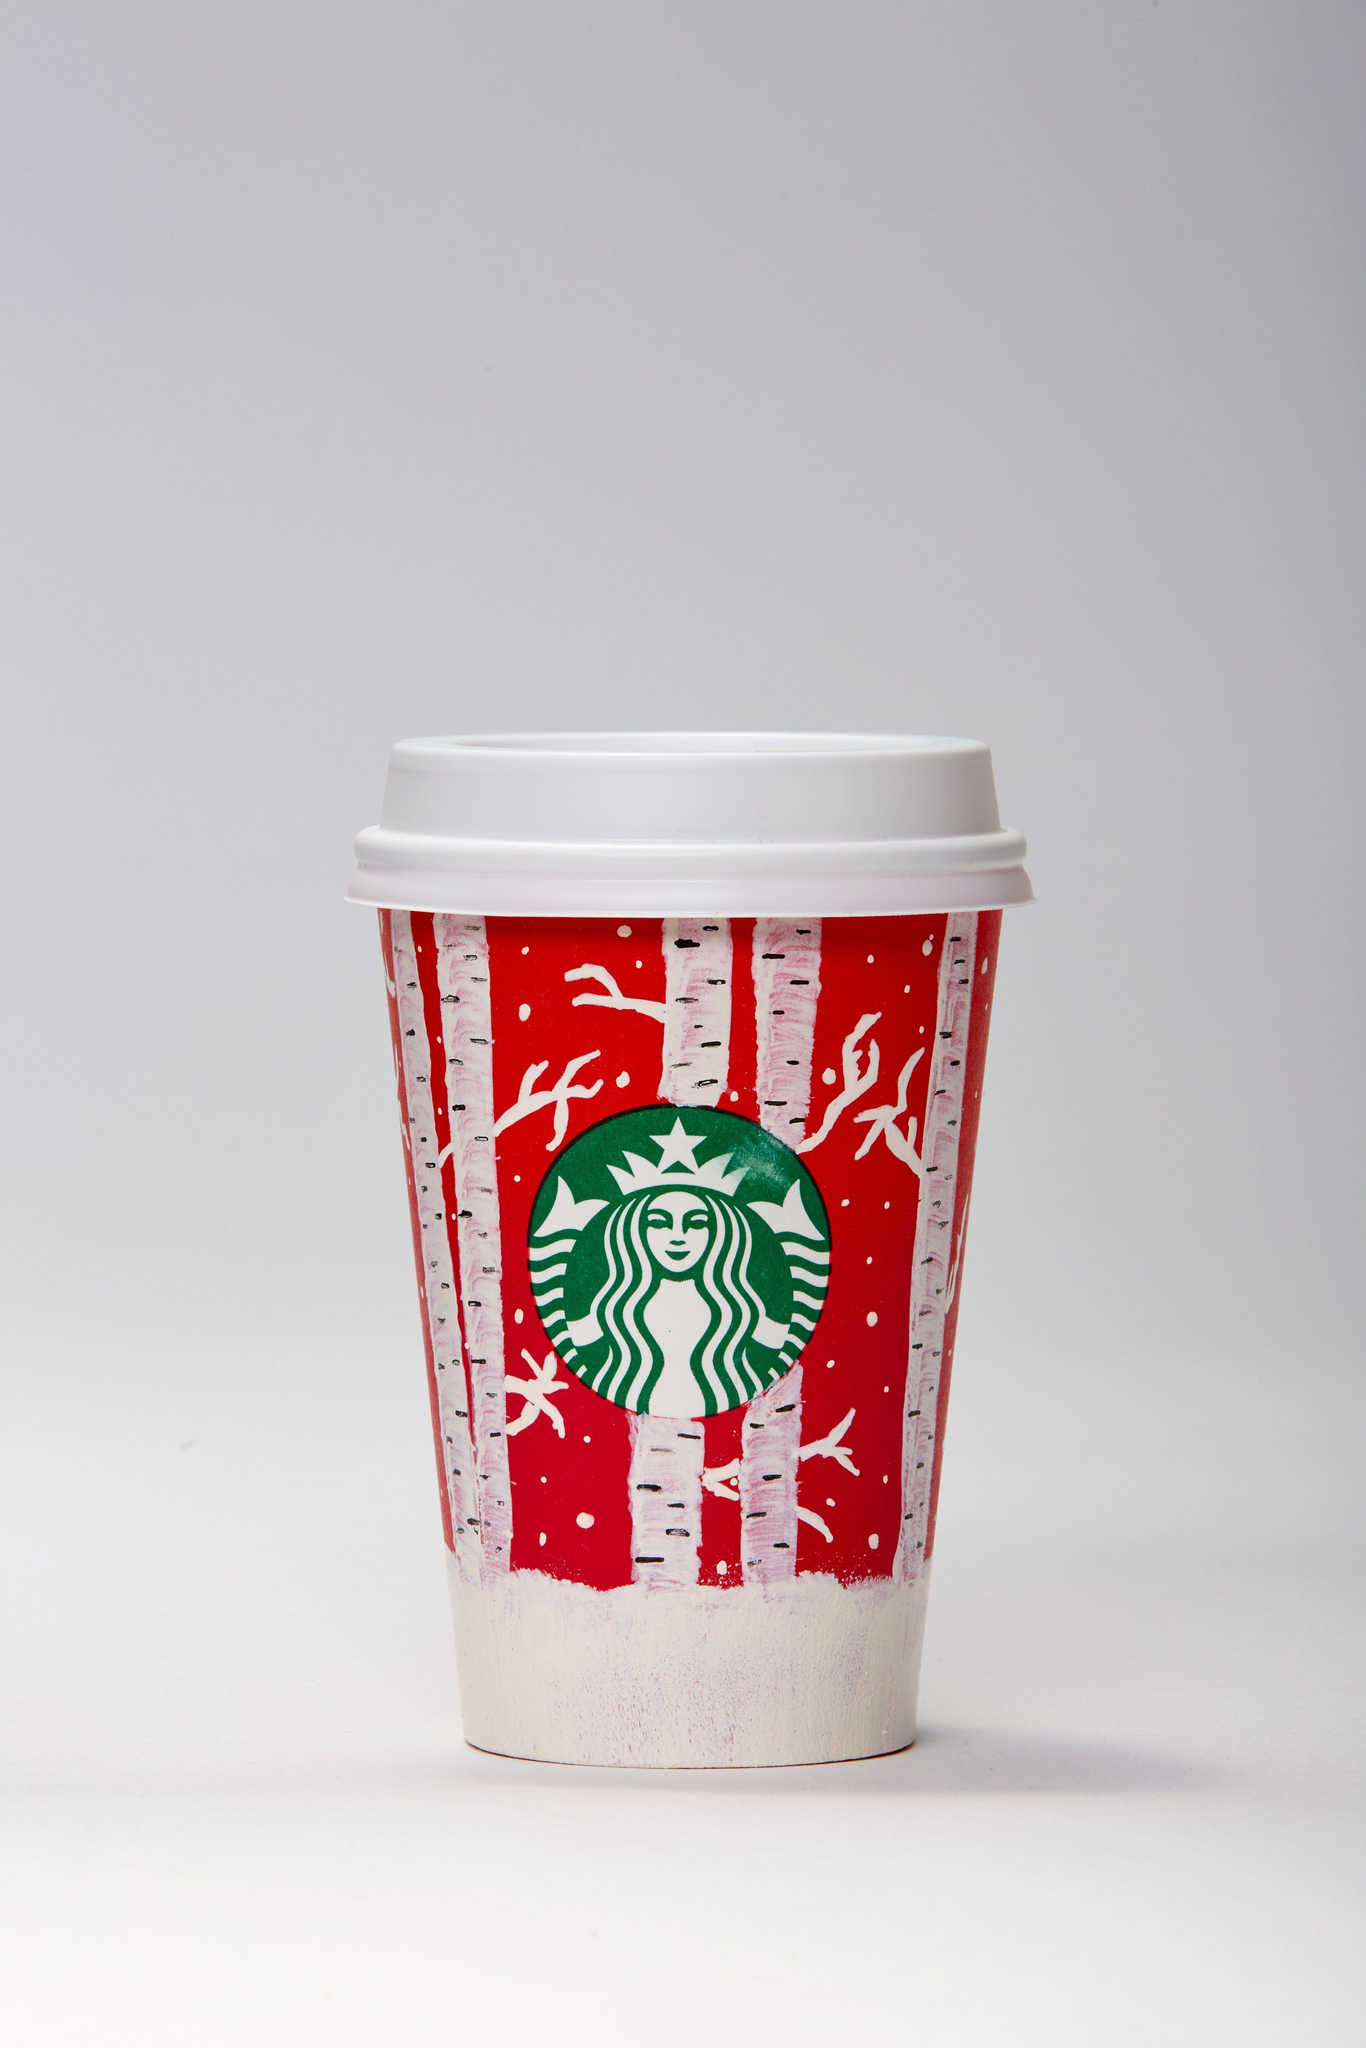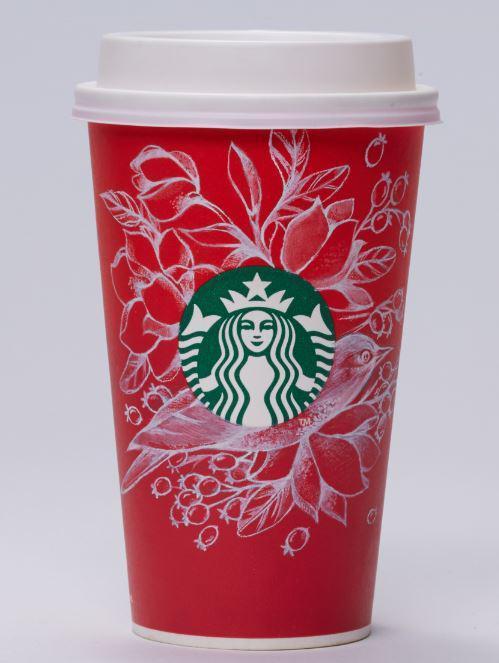The first image is the image on the left, the second image is the image on the right. Examine the images to the left and right. Is the description "There are exactly two cups." accurate? Answer yes or no. Yes. 